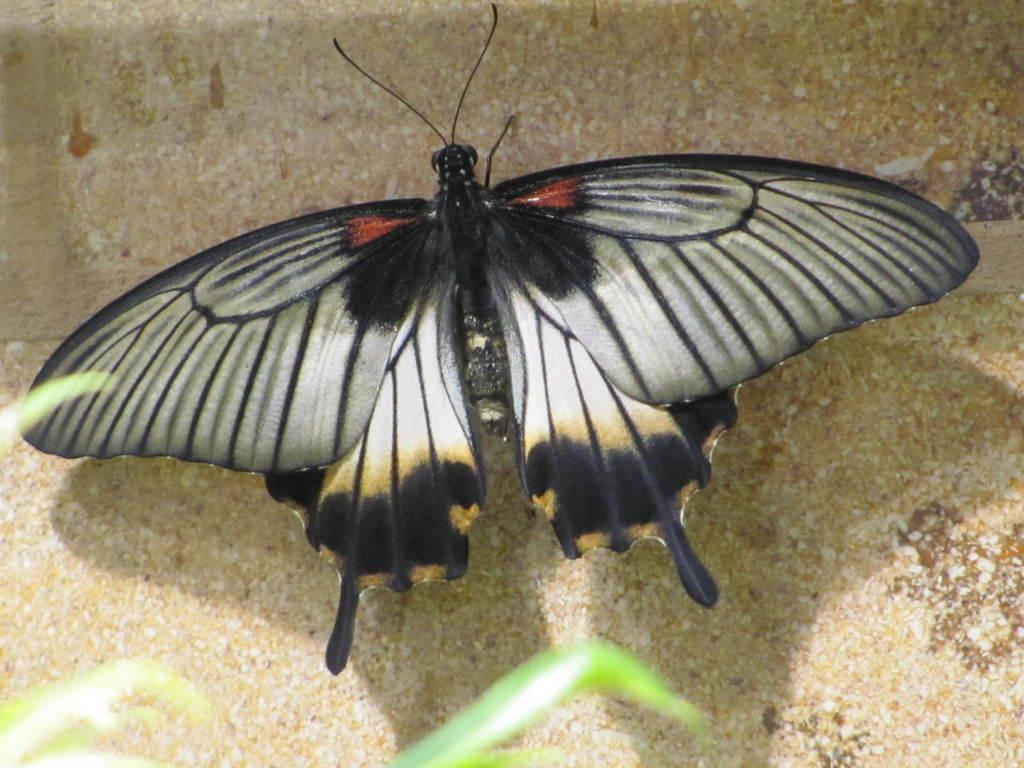What is the main subject of the image? There is a butterfly in the image. Where is the butterfly located? The butterfly is on the wall. How many goats are visible in the image? There are no goats present in the image; it features a butterfly on the wall. What type of laborer is shown working with the ducks in the image? There are no ducks or laborers present in the image; it features a butterfly on the wall. 